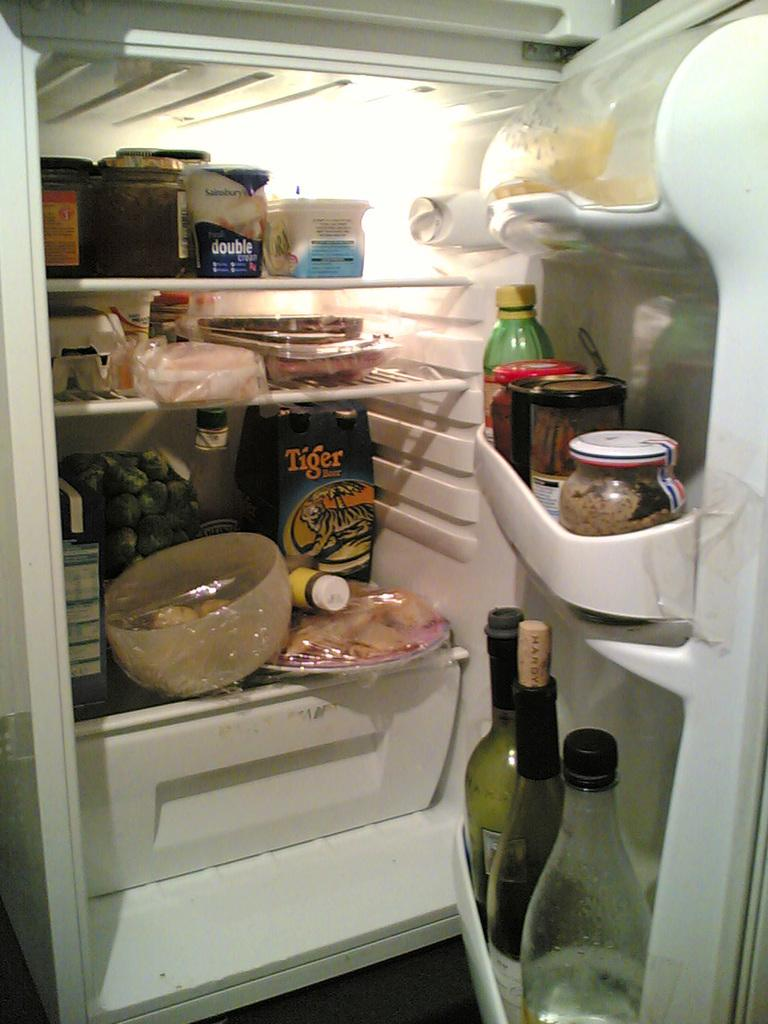Provide a one-sentence caption for the provided image. A package labeled "Tiger" sits on the lower shelf of a very full refrigerator. 